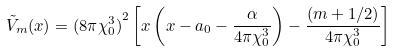<formula> <loc_0><loc_0><loc_500><loc_500>\tilde { V } _ { m } ( x ) = { ( 8 \pi \chi _ { 0 } ^ { 3 } ) } ^ { 2 } \left [ x \left ( x - a _ { 0 } - \frac { \alpha } { 4 \pi \chi _ { 0 } ^ { 3 } } \right ) - \frac { ( m + 1 / 2 ) } { 4 \pi \chi _ { 0 } ^ { 3 } } \right ]</formula> 